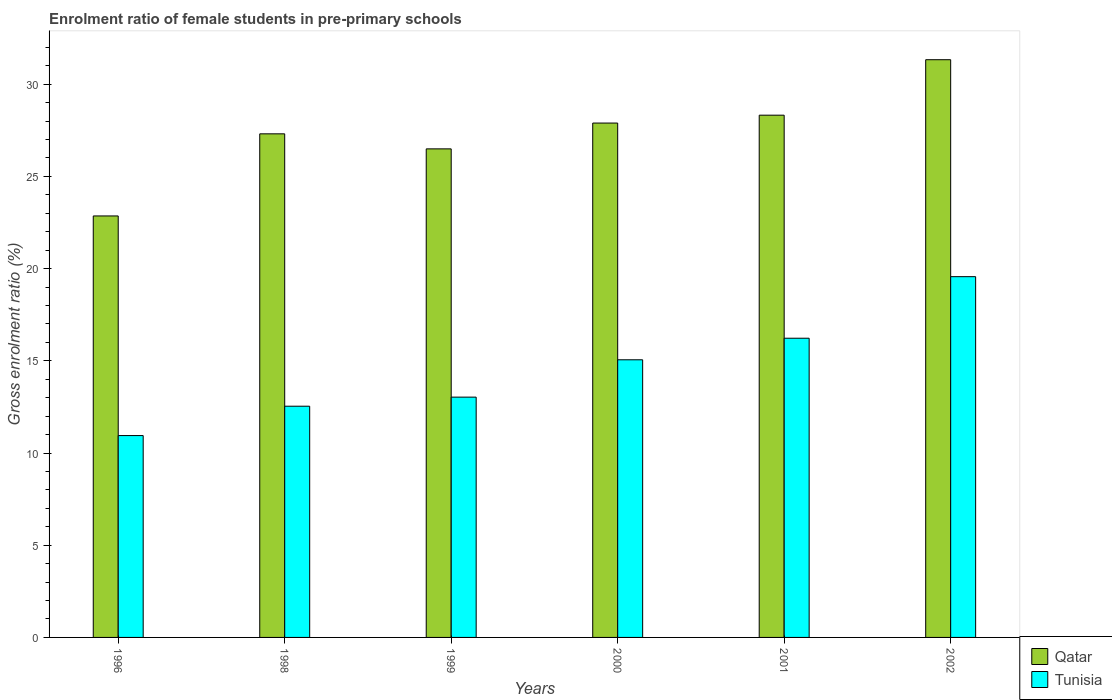How many different coloured bars are there?
Ensure brevity in your answer.  2. Are the number of bars on each tick of the X-axis equal?
Offer a terse response. Yes. How many bars are there on the 1st tick from the left?
Your response must be concise. 2. How many bars are there on the 2nd tick from the right?
Provide a succinct answer. 2. What is the label of the 5th group of bars from the left?
Offer a very short reply. 2001. What is the enrolment ratio of female students in pre-primary schools in Qatar in 2001?
Your response must be concise. 28.32. Across all years, what is the maximum enrolment ratio of female students in pre-primary schools in Qatar?
Your response must be concise. 31.33. Across all years, what is the minimum enrolment ratio of female students in pre-primary schools in Qatar?
Offer a very short reply. 22.85. In which year was the enrolment ratio of female students in pre-primary schools in Tunisia maximum?
Provide a short and direct response. 2002. In which year was the enrolment ratio of female students in pre-primary schools in Qatar minimum?
Your answer should be very brief. 1996. What is the total enrolment ratio of female students in pre-primary schools in Qatar in the graph?
Make the answer very short. 164.19. What is the difference between the enrolment ratio of female students in pre-primary schools in Qatar in 1998 and that in 2002?
Offer a very short reply. -4.02. What is the difference between the enrolment ratio of female students in pre-primary schools in Tunisia in 2000 and the enrolment ratio of female students in pre-primary schools in Qatar in 1996?
Offer a very short reply. -7.8. What is the average enrolment ratio of female students in pre-primary schools in Tunisia per year?
Your answer should be very brief. 14.56. In the year 1996, what is the difference between the enrolment ratio of female students in pre-primary schools in Tunisia and enrolment ratio of female students in pre-primary schools in Qatar?
Your response must be concise. -11.91. In how many years, is the enrolment ratio of female students in pre-primary schools in Qatar greater than 13 %?
Offer a very short reply. 6. What is the ratio of the enrolment ratio of female students in pre-primary schools in Tunisia in 1996 to that in 1998?
Offer a very short reply. 0.87. What is the difference between the highest and the second highest enrolment ratio of female students in pre-primary schools in Qatar?
Your answer should be compact. 3.01. What is the difference between the highest and the lowest enrolment ratio of female students in pre-primary schools in Tunisia?
Give a very brief answer. 8.62. What does the 2nd bar from the left in 2001 represents?
Keep it short and to the point. Tunisia. What does the 1st bar from the right in 1998 represents?
Offer a very short reply. Tunisia. How many bars are there?
Your answer should be very brief. 12. What is the difference between two consecutive major ticks on the Y-axis?
Your answer should be very brief. 5. Are the values on the major ticks of Y-axis written in scientific E-notation?
Offer a very short reply. No. Does the graph contain any zero values?
Offer a very short reply. No. Does the graph contain grids?
Your answer should be very brief. No. Where does the legend appear in the graph?
Provide a succinct answer. Bottom right. What is the title of the graph?
Make the answer very short. Enrolment ratio of female students in pre-primary schools. Does "Finland" appear as one of the legend labels in the graph?
Give a very brief answer. No. What is the label or title of the Y-axis?
Provide a succinct answer. Gross enrolment ratio (%). What is the Gross enrolment ratio (%) of Qatar in 1996?
Your response must be concise. 22.85. What is the Gross enrolment ratio (%) of Tunisia in 1996?
Offer a terse response. 10.94. What is the Gross enrolment ratio (%) of Qatar in 1998?
Keep it short and to the point. 27.31. What is the Gross enrolment ratio (%) of Tunisia in 1998?
Make the answer very short. 12.54. What is the Gross enrolment ratio (%) of Qatar in 1999?
Give a very brief answer. 26.49. What is the Gross enrolment ratio (%) in Tunisia in 1999?
Provide a succinct answer. 13.03. What is the Gross enrolment ratio (%) of Qatar in 2000?
Keep it short and to the point. 27.89. What is the Gross enrolment ratio (%) in Tunisia in 2000?
Ensure brevity in your answer.  15.05. What is the Gross enrolment ratio (%) in Qatar in 2001?
Offer a very short reply. 28.32. What is the Gross enrolment ratio (%) of Tunisia in 2001?
Your answer should be very brief. 16.22. What is the Gross enrolment ratio (%) of Qatar in 2002?
Your answer should be compact. 31.33. What is the Gross enrolment ratio (%) in Tunisia in 2002?
Your answer should be compact. 19.56. Across all years, what is the maximum Gross enrolment ratio (%) in Qatar?
Provide a succinct answer. 31.33. Across all years, what is the maximum Gross enrolment ratio (%) of Tunisia?
Your response must be concise. 19.56. Across all years, what is the minimum Gross enrolment ratio (%) of Qatar?
Offer a very short reply. 22.85. Across all years, what is the minimum Gross enrolment ratio (%) in Tunisia?
Offer a terse response. 10.94. What is the total Gross enrolment ratio (%) in Qatar in the graph?
Provide a succinct answer. 164.19. What is the total Gross enrolment ratio (%) of Tunisia in the graph?
Provide a succinct answer. 87.35. What is the difference between the Gross enrolment ratio (%) of Qatar in 1996 and that in 1998?
Your answer should be compact. -4.45. What is the difference between the Gross enrolment ratio (%) in Tunisia in 1996 and that in 1998?
Ensure brevity in your answer.  -1.59. What is the difference between the Gross enrolment ratio (%) of Qatar in 1996 and that in 1999?
Provide a short and direct response. -3.64. What is the difference between the Gross enrolment ratio (%) in Tunisia in 1996 and that in 1999?
Your answer should be very brief. -2.08. What is the difference between the Gross enrolment ratio (%) of Qatar in 1996 and that in 2000?
Keep it short and to the point. -5.04. What is the difference between the Gross enrolment ratio (%) in Tunisia in 1996 and that in 2000?
Ensure brevity in your answer.  -4.11. What is the difference between the Gross enrolment ratio (%) in Qatar in 1996 and that in 2001?
Provide a short and direct response. -5.46. What is the difference between the Gross enrolment ratio (%) of Tunisia in 1996 and that in 2001?
Your answer should be compact. -5.28. What is the difference between the Gross enrolment ratio (%) in Qatar in 1996 and that in 2002?
Offer a terse response. -8.47. What is the difference between the Gross enrolment ratio (%) of Tunisia in 1996 and that in 2002?
Provide a short and direct response. -8.62. What is the difference between the Gross enrolment ratio (%) of Qatar in 1998 and that in 1999?
Give a very brief answer. 0.82. What is the difference between the Gross enrolment ratio (%) of Tunisia in 1998 and that in 1999?
Give a very brief answer. -0.49. What is the difference between the Gross enrolment ratio (%) in Qatar in 1998 and that in 2000?
Your answer should be very brief. -0.58. What is the difference between the Gross enrolment ratio (%) in Tunisia in 1998 and that in 2000?
Your answer should be very brief. -2.52. What is the difference between the Gross enrolment ratio (%) of Qatar in 1998 and that in 2001?
Ensure brevity in your answer.  -1.01. What is the difference between the Gross enrolment ratio (%) of Tunisia in 1998 and that in 2001?
Your answer should be compact. -3.69. What is the difference between the Gross enrolment ratio (%) of Qatar in 1998 and that in 2002?
Your response must be concise. -4.02. What is the difference between the Gross enrolment ratio (%) in Tunisia in 1998 and that in 2002?
Keep it short and to the point. -7.02. What is the difference between the Gross enrolment ratio (%) of Qatar in 1999 and that in 2000?
Offer a very short reply. -1.4. What is the difference between the Gross enrolment ratio (%) of Tunisia in 1999 and that in 2000?
Provide a succinct answer. -2.03. What is the difference between the Gross enrolment ratio (%) of Qatar in 1999 and that in 2001?
Provide a succinct answer. -1.83. What is the difference between the Gross enrolment ratio (%) of Tunisia in 1999 and that in 2001?
Your answer should be very brief. -3.19. What is the difference between the Gross enrolment ratio (%) of Qatar in 1999 and that in 2002?
Your answer should be compact. -4.83. What is the difference between the Gross enrolment ratio (%) in Tunisia in 1999 and that in 2002?
Make the answer very short. -6.53. What is the difference between the Gross enrolment ratio (%) of Qatar in 2000 and that in 2001?
Your answer should be compact. -0.43. What is the difference between the Gross enrolment ratio (%) in Tunisia in 2000 and that in 2001?
Give a very brief answer. -1.17. What is the difference between the Gross enrolment ratio (%) of Qatar in 2000 and that in 2002?
Offer a terse response. -3.44. What is the difference between the Gross enrolment ratio (%) in Tunisia in 2000 and that in 2002?
Give a very brief answer. -4.51. What is the difference between the Gross enrolment ratio (%) in Qatar in 2001 and that in 2002?
Offer a very short reply. -3.01. What is the difference between the Gross enrolment ratio (%) of Tunisia in 2001 and that in 2002?
Provide a succinct answer. -3.34. What is the difference between the Gross enrolment ratio (%) in Qatar in 1996 and the Gross enrolment ratio (%) in Tunisia in 1998?
Offer a terse response. 10.32. What is the difference between the Gross enrolment ratio (%) of Qatar in 1996 and the Gross enrolment ratio (%) of Tunisia in 1999?
Provide a succinct answer. 9.82. What is the difference between the Gross enrolment ratio (%) in Qatar in 1996 and the Gross enrolment ratio (%) in Tunisia in 2000?
Make the answer very short. 7.8. What is the difference between the Gross enrolment ratio (%) of Qatar in 1996 and the Gross enrolment ratio (%) of Tunisia in 2001?
Your answer should be compact. 6.63. What is the difference between the Gross enrolment ratio (%) in Qatar in 1996 and the Gross enrolment ratio (%) in Tunisia in 2002?
Ensure brevity in your answer.  3.29. What is the difference between the Gross enrolment ratio (%) in Qatar in 1998 and the Gross enrolment ratio (%) in Tunisia in 1999?
Provide a short and direct response. 14.28. What is the difference between the Gross enrolment ratio (%) in Qatar in 1998 and the Gross enrolment ratio (%) in Tunisia in 2000?
Offer a terse response. 12.25. What is the difference between the Gross enrolment ratio (%) in Qatar in 1998 and the Gross enrolment ratio (%) in Tunisia in 2001?
Ensure brevity in your answer.  11.08. What is the difference between the Gross enrolment ratio (%) in Qatar in 1998 and the Gross enrolment ratio (%) in Tunisia in 2002?
Your response must be concise. 7.74. What is the difference between the Gross enrolment ratio (%) in Qatar in 1999 and the Gross enrolment ratio (%) in Tunisia in 2000?
Provide a short and direct response. 11.44. What is the difference between the Gross enrolment ratio (%) in Qatar in 1999 and the Gross enrolment ratio (%) in Tunisia in 2001?
Provide a succinct answer. 10.27. What is the difference between the Gross enrolment ratio (%) in Qatar in 1999 and the Gross enrolment ratio (%) in Tunisia in 2002?
Your answer should be very brief. 6.93. What is the difference between the Gross enrolment ratio (%) in Qatar in 2000 and the Gross enrolment ratio (%) in Tunisia in 2001?
Provide a succinct answer. 11.67. What is the difference between the Gross enrolment ratio (%) in Qatar in 2000 and the Gross enrolment ratio (%) in Tunisia in 2002?
Keep it short and to the point. 8.33. What is the difference between the Gross enrolment ratio (%) in Qatar in 2001 and the Gross enrolment ratio (%) in Tunisia in 2002?
Make the answer very short. 8.76. What is the average Gross enrolment ratio (%) in Qatar per year?
Make the answer very short. 27.36. What is the average Gross enrolment ratio (%) in Tunisia per year?
Your response must be concise. 14.56. In the year 1996, what is the difference between the Gross enrolment ratio (%) of Qatar and Gross enrolment ratio (%) of Tunisia?
Your answer should be very brief. 11.91. In the year 1998, what is the difference between the Gross enrolment ratio (%) in Qatar and Gross enrolment ratio (%) in Tunisia?
Provide a short and direct response. 14.77. In the year 1999, what is the difference between the Gross enrolment ratio (%) in Qatar and Gross enrolment ratio (%) in Tunisia?
Provide a succinct answer. 13.46. In the year 2000, what is the difference between the Gross enrolment ratio (%) of Qatar and Gross enrolment ratio (%) of Tunisia?
Offer a terse response. 12.84. In the year 2001, what is the difference between the Gross enrolment ratio (%) in Qatar and Gross enrolment ratio (%) in Tunisia?
Provide a succinct answer. 12.09. In the year 2002, what is the difference between the Gross enrolment ratio (%) of Qatar and Gross enrolment ratio (%) of Tunisia?
Your answer should be compact. 11.76. What is the ratio of the Gross enrolment ratio (%) of Qatar in 1996 to that in 1998?
Provide a short and direct response. 0.84. What is the ratio of the Gross enrolment ratio (%) in Tunisia in 1996 to that in 1998?
Provide a short and direct response. 0.87. What is the ratio of the Gross enrolment ratio (%) of Qatar in 1996 to that in 1999?
Offer a terse response. 0.86. What is the ratio of the Gross enrolment ratio (%) in Tunisia in 1996 to that in 1999?
Offer a very short reply. 0.84. What is the ratio of the Gross enrolment ratio (%) of Qatar in 1996 to that in 2000?
Your answer should be very brief. 0.82. What is the ratio of the Gross enrolment ratio (%) of Tunisia in 1996 to that in 2000?
Provide a short and direct response. 0.73. What is the ratio of the Gross enrolment ratio (%) of Qatar in 1996 to that in 2001?
Give a very brief answer. 0.81. What is the ratio of the Gross enrolment ratio (%) in Tunisia in 1996 to that in 2001?
Your response must be concise. 0.67. What is the ratio of the Gross enrolment ratio (%) in Qatar in 1996 to that in 2002?
Ensure brevity in your answer.  0.73. What is the ratio of the Gross enrolment ratio (%) in Tunisia in 1996 to that in 2002?
Give a very brief answer. 0.56. What is the ratio of the Gross enrolment ratio (%) of Qatar in 1998 to that in 1999?
Make the answer very short. 1.03. What is the ratio of the Gross enrolment ratio (%) of Tunisia in 1998 to that in 1999?
Offer a terse response. 0.96. What is the ratio of the Gross enrolment ratio (%) of Qatar in 1998 to that in 2000?
Provide a succinct answer. 0.98. What is the ratio of the Gross enrolment ratio (%) of Tunisia in 1998 to that in 2000?
Keep it short and to the point. 0.83. What is the ratio of the Gross enrolment ratio (%) in Tunisia in 1998 to that in 2001?
Provide a succinct answer. 0.77. What is the ratio of the Gross enrolment ratio (%) of Qatar in 1998 to that in 2002?
Make the answer very short. 0.87. What is the ratio of the Gross enrolment ratio (%) of Tunisia in 1998 to that in 2002?
Offer a terse response. 0.64. What is the ratio of the Gross enrolment ratio (%) of Qatar in 1999 to that in 2000?
Ensure brevity in your answer.  0.95. What is the ratio of the Gross enrolment ratio (%) in Tunisia in 1999 to that in 2000?
Your response must be concise. 0.87. What is the ratio of the Gross enrolment ratio (%) in Qatar in 1999 to that in 2001?
Offer a terse response. 0.94. What is the ratio of the Gross enrolment ratio (%) of Tunisia in 1999 to that in 2001?
Provide a succinct answer. 0.8. What is the ratio of the Gross enrolment ratio (%) in Qatar in 1999 to that in 2002?
Ensure brevity in your answer.  0.85. What is the ratio of the Gross enrolment ratio (%) in Tunisia in 1999 to that in 2002?
Offer a terse response. 0.67. What is the ratio of the Gross enrolment ratio (%) of Qatar in 2000 to that in 2001?
Ensure brevity in your answer.  0.98. What is the ratio of the Gross enrolment ratio (%) in Tunisia in 2000 to that in 2001?
Keep it short and to the point. 0.93. What is the ratio of the Gross enrolment ratio (%) in Qatar in 2000 to that in 2002?
Make the answer very short. 0.89. What is the ratio of the Gross enrolment ratio (%) of Tunisia in 2000 to that in 2002?
Your response must be concise. 0.77. What is the ratio of the Gross enrolment ratio (%) of Qatar in 2001 to that in 2002?
Your answer should be very brief. 0.9. What is the ratio of the Gross enrolment ratio (%) of Tunisia in 2001 to that in 2002?
Ensure brevity in your answer.  0.83. What is the difference between the highest and the second highest Gross enrolment ratio (%) in Qatar?
Provide a short and direct response. 3.01. What is the difference between the highest and the second highest Gross enrolment ratio (%) in Tunisia?
Ensure brevity in your answer.  3.34. What is the difference between the highest and the lowest Gross enrolment ratio (%) in Qatar?
Provide a succinct answer. 8.47. What is the difference between the highest and the lowest Gross enrolment ratio (%) in Tunisia?
Keep it short and to the point. 8.62. 